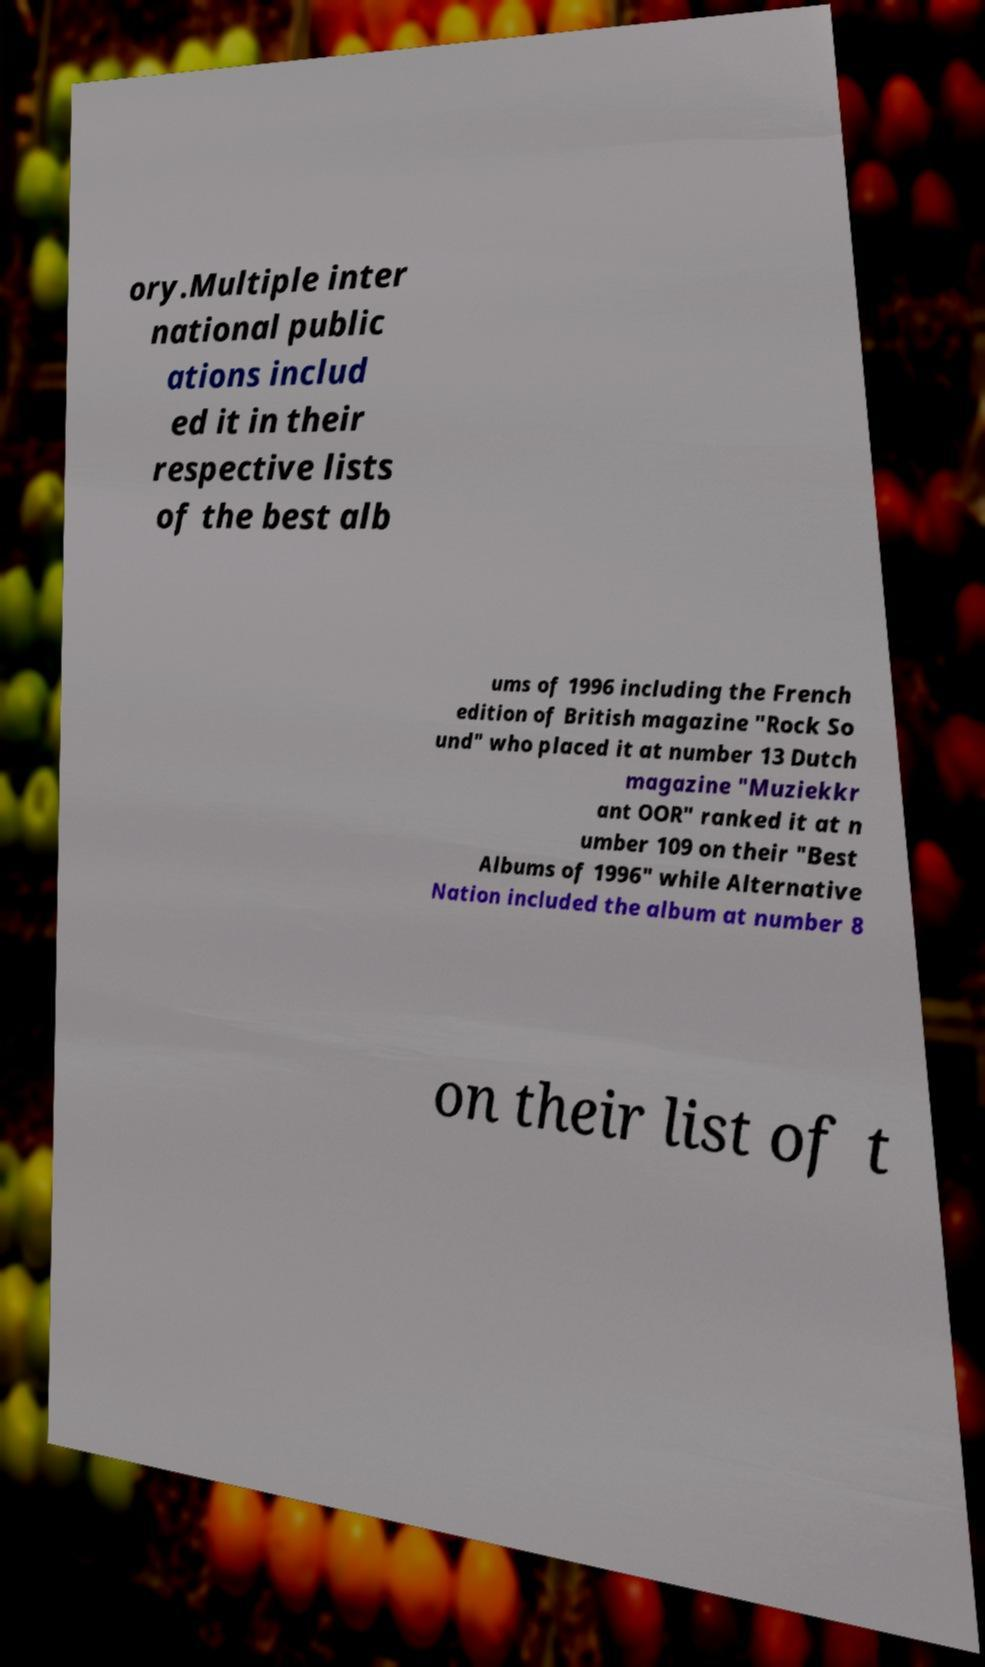What messages or text are displayed in this image? I need them in a readable, typed format. ory.Multiple inter national public ations includ ed it in their respective lists of the best alb ums of 1996 including the French edition of British magazine "Rock So und" who placed it at number 13 Dutch magazine "Muziekkr ant OOR" ranked it at n umber 109 on their "Best Albums of 1996" while Alternative Nation included the album at number 8 on their list of t 